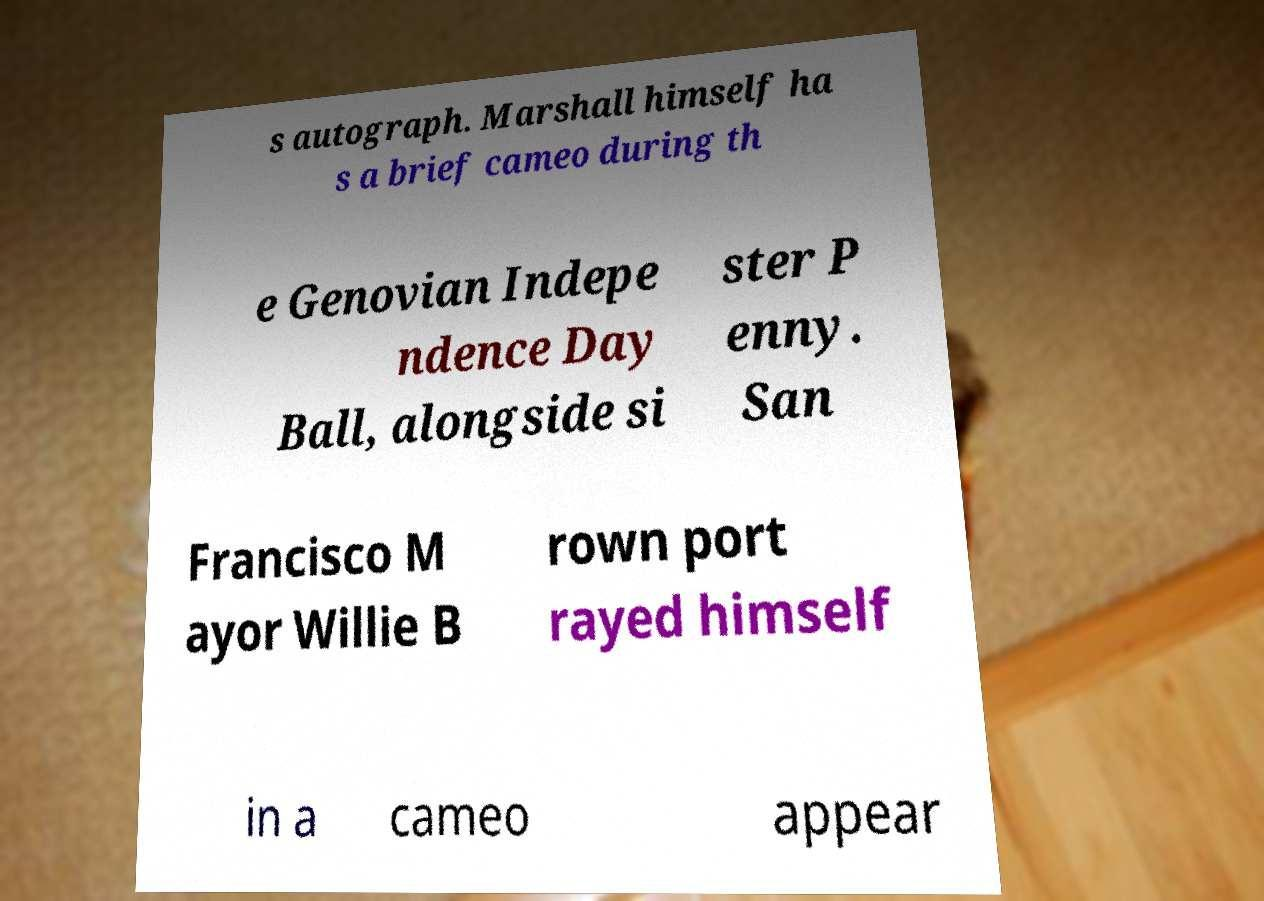Please read and relay the text visible in this image. What does it say? s autograph. Marshall himself ha s a brief cameo during th e Genovian Indepe ndence Day Ball, alongside si ster P enny. San Francisco M ayor Willie B rown port rayed himself in a cameo appear 